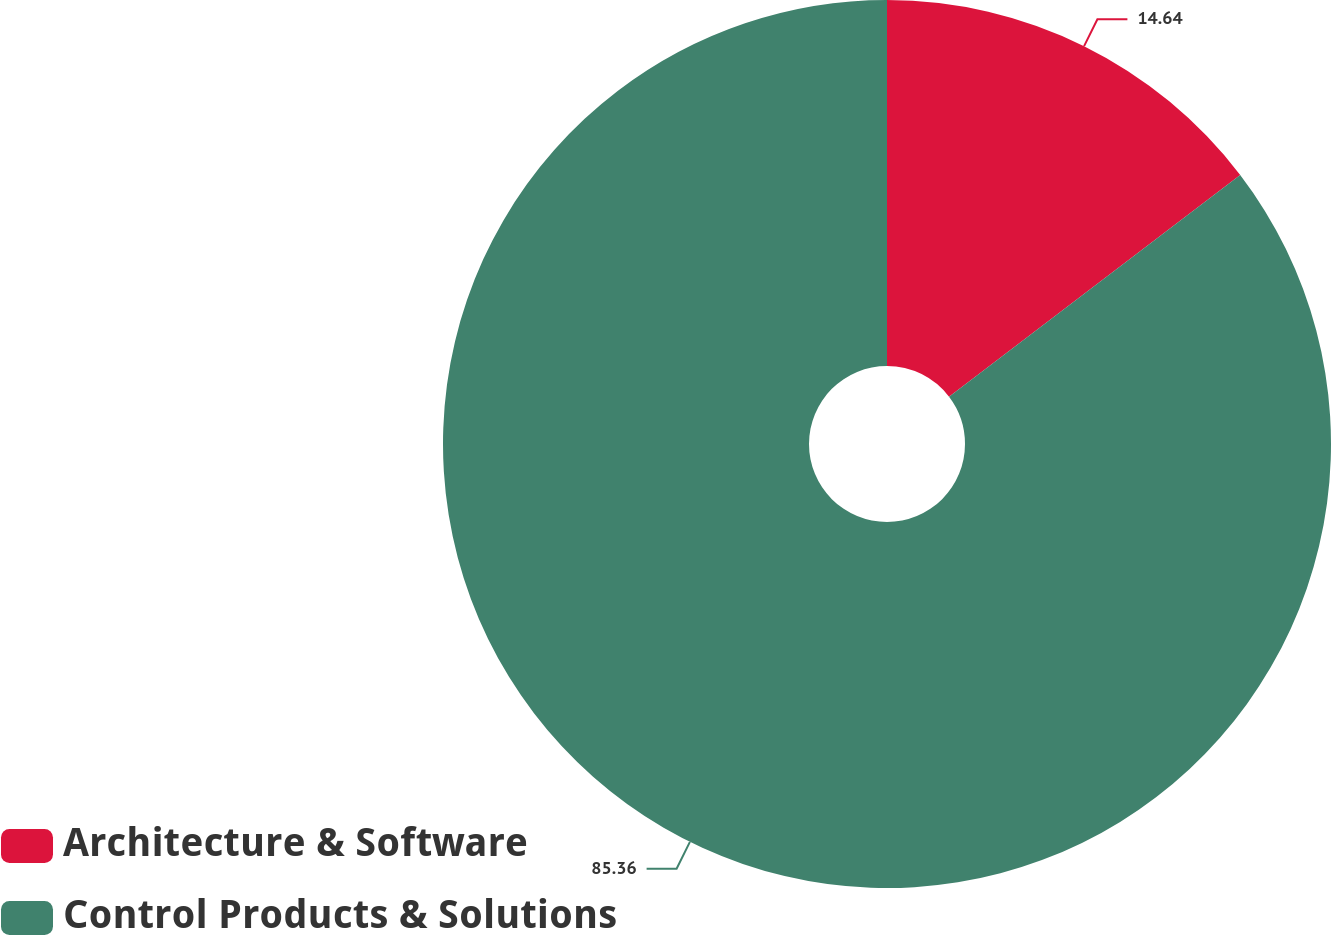<chart> <loc_0><loc_0><loc_500><loc_500><pie_chart><fcel>Architecture & Software<fcel>Control Products & Solutions<nl><fcel>14.64%<fcel>85.36%<nl></chart> 